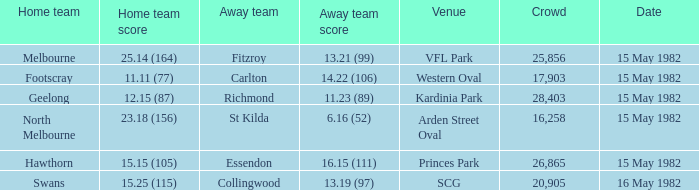Where did North Melbourne play as the home team? Arden Street Oval. 